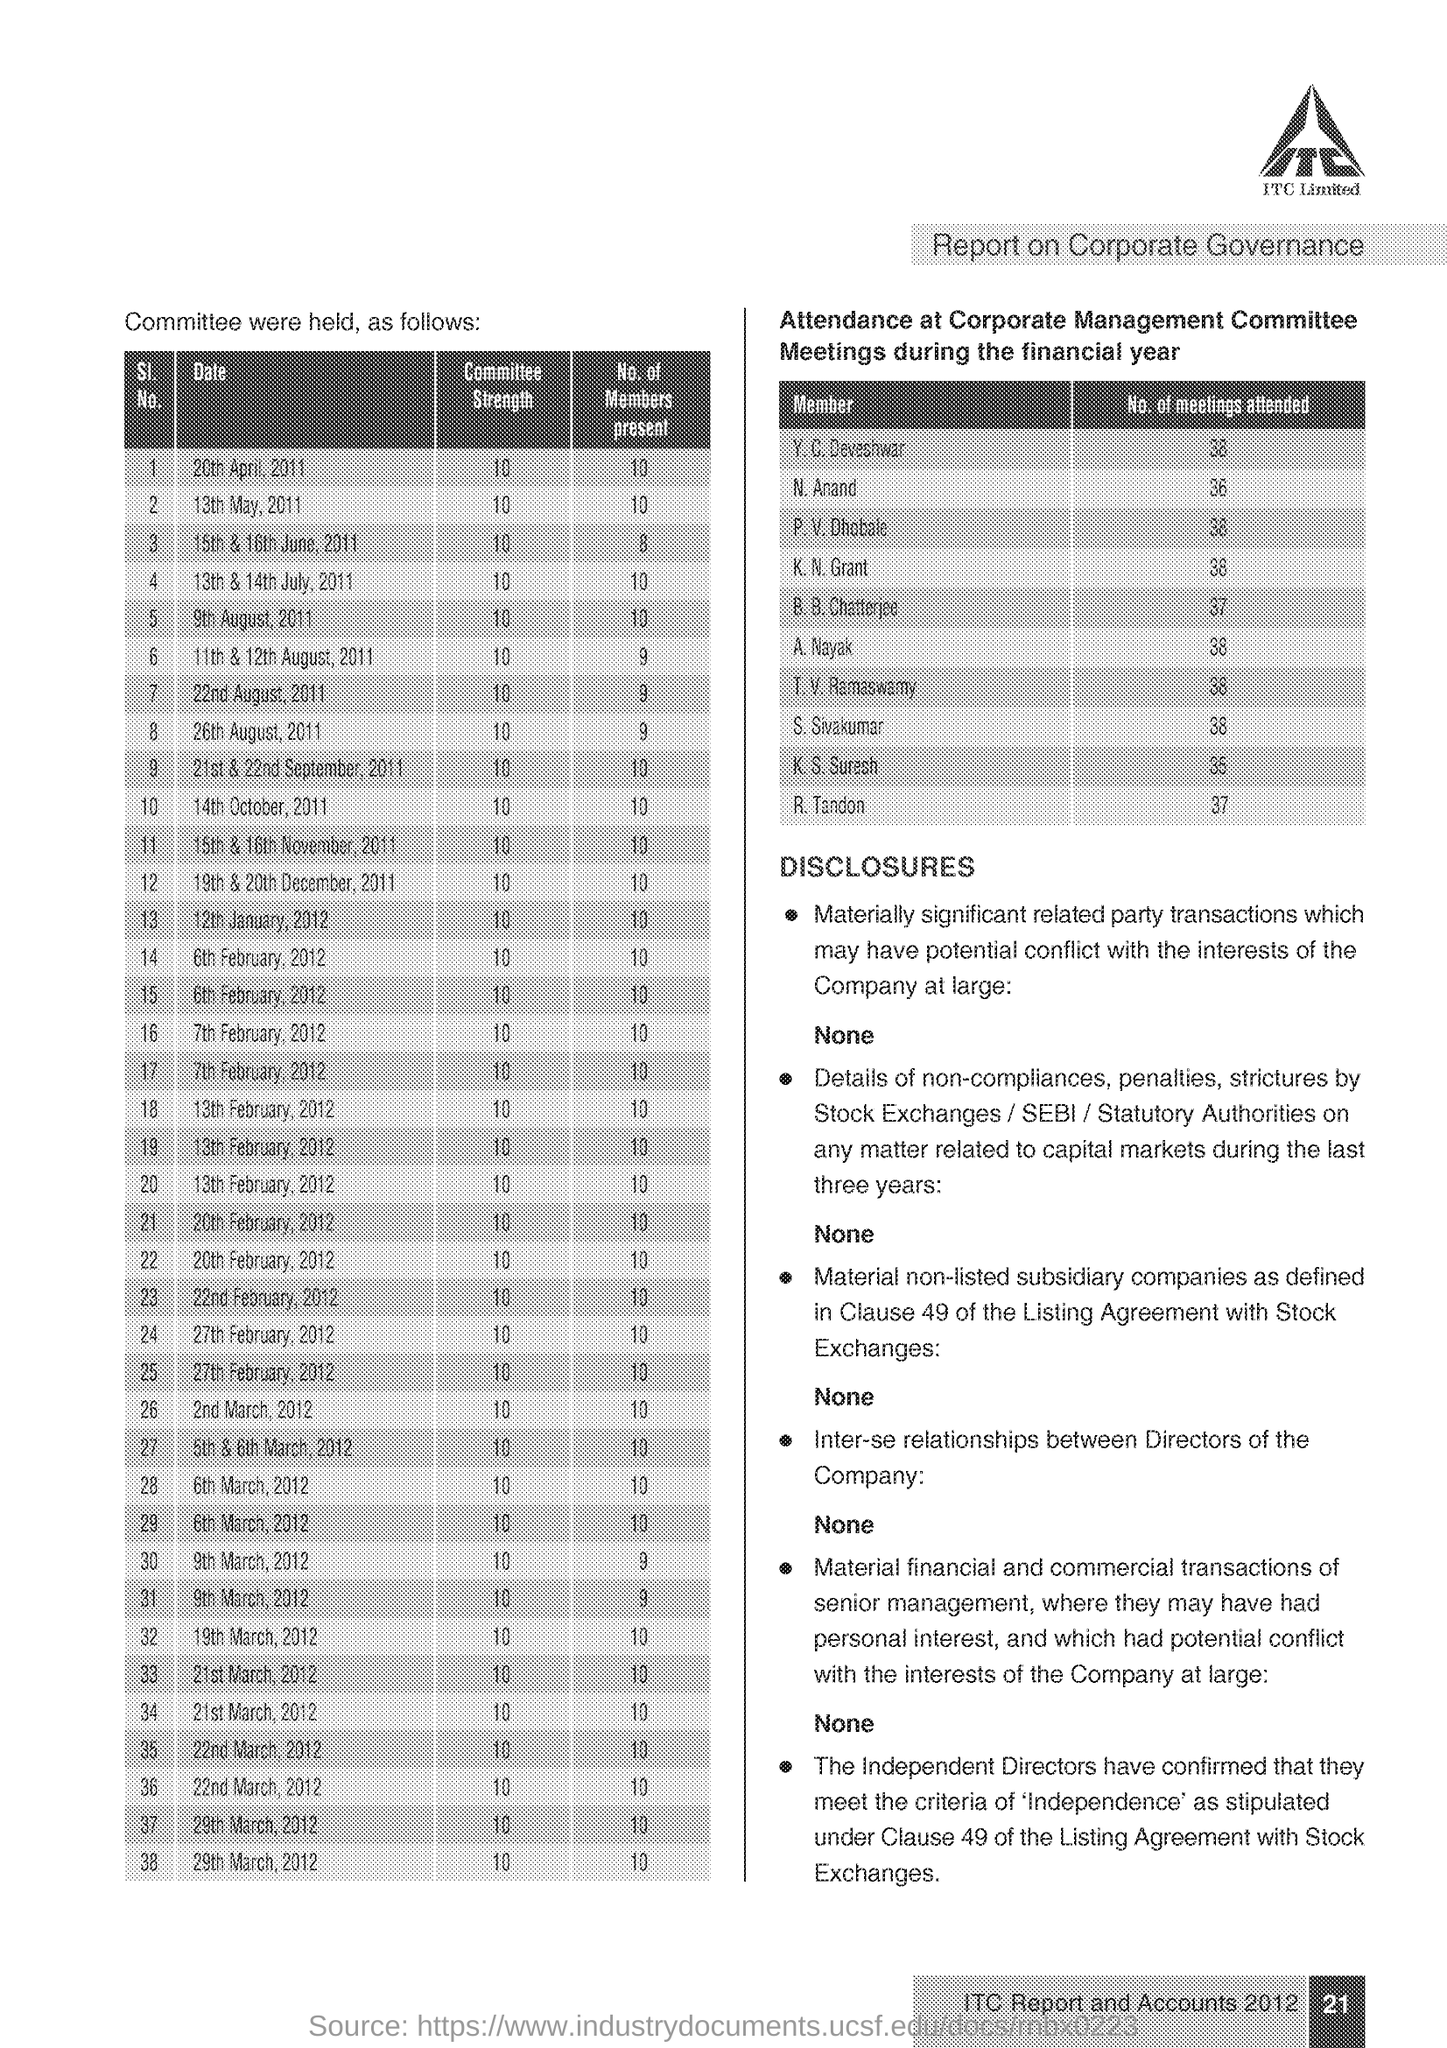What is the Committee Strength in 13th May, 2011 ?
Give a very brief answer. 10. How many meetings attended the N. Anand ?
Give a very brief answer. 36. How many Members present in 14th October, 2011?
Provide a succinct answer. 10. What is the Company Name ?
Your answer should be very brief. ITC Limited. 